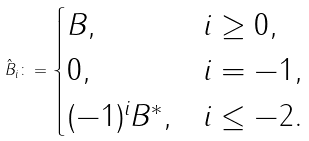Convert formula to latex. <formula><loc_0><loc_0><loc_500><loc_500>\hat { B } _ { i } \colon = \begin{cases} B , & i \geq 0 , \\ 0 , & i = - 1 , \\ ( - 1 ) ^ { i } B ^ { * } , & i \leq - 2 . \end{cases}</formula> 